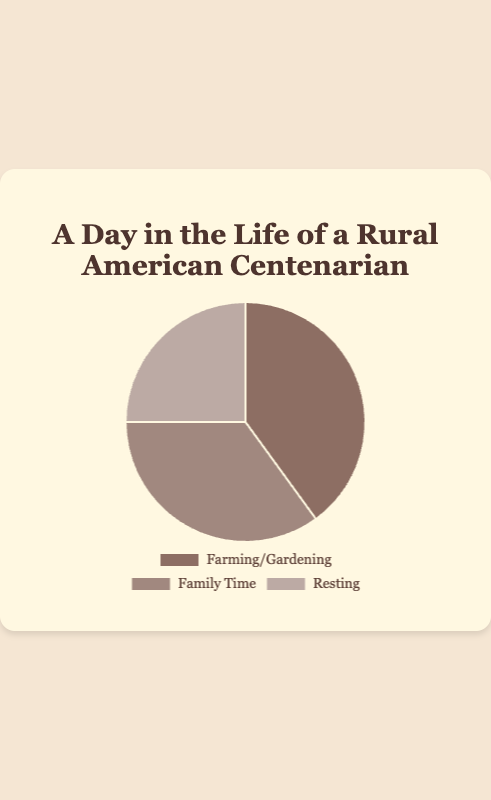How much more time is spent on Farming/Gardening compared to Resting? First, note the time spent on Farming/Gardening (40%) and on Resting (25%). Subtract the time spent on Resting from the time spent on Farming/Gardening: 40% - 25% = 15%.
Answer: 15% Which activity takes up the largest portion of the day? Examine the pie chart sections or the data and find the activity with the highest percentage. Farming/Gardening has the largest portion with 40%.
Answer: Farming/Gardening Is there more time spent on Family Time or Resting? Compare the percentages for Family Time (35%) and Resting (25%). Family Time has a higher percentage.
Answer: Family Time What fraction of the day is spent on Resting? Note the percentage for Resting which is 25%. To convert this percentage to a fraction: 25/100 = 1/4 or one-fourth of the day.
Answer: 1/4 What is the combined percentage of time spent on Farming/Gardening and Resting? Add the percentages for Farming/Gardening (40%) and Resting (25%). 40% + 25% = 65%.
Answer: 65% How does the time spent on Family Time compare to the time spent on Farming/Gardening? Compare the percentages for Family Time (35%) and Farming/Gardening (40%). Family Time is 5% less than Farming/Gardening.
Answer: Farming/Gardening is 5% more What is the difference between the largest and smallest time portions? Identify the largest portion (Farming/Gardening at 40%) and the smallest (Resting at 25%). Subtract the smallest from the largest: 40% - 25% = 15%.
Answer: 15% What colors represent the activities on the chart? Observe the chart and note the colors corresponding to each segment. Farming/Gardening is brown, Family Time is tan, and Resting is light brown.
Answer: Brown, tan, light brown 